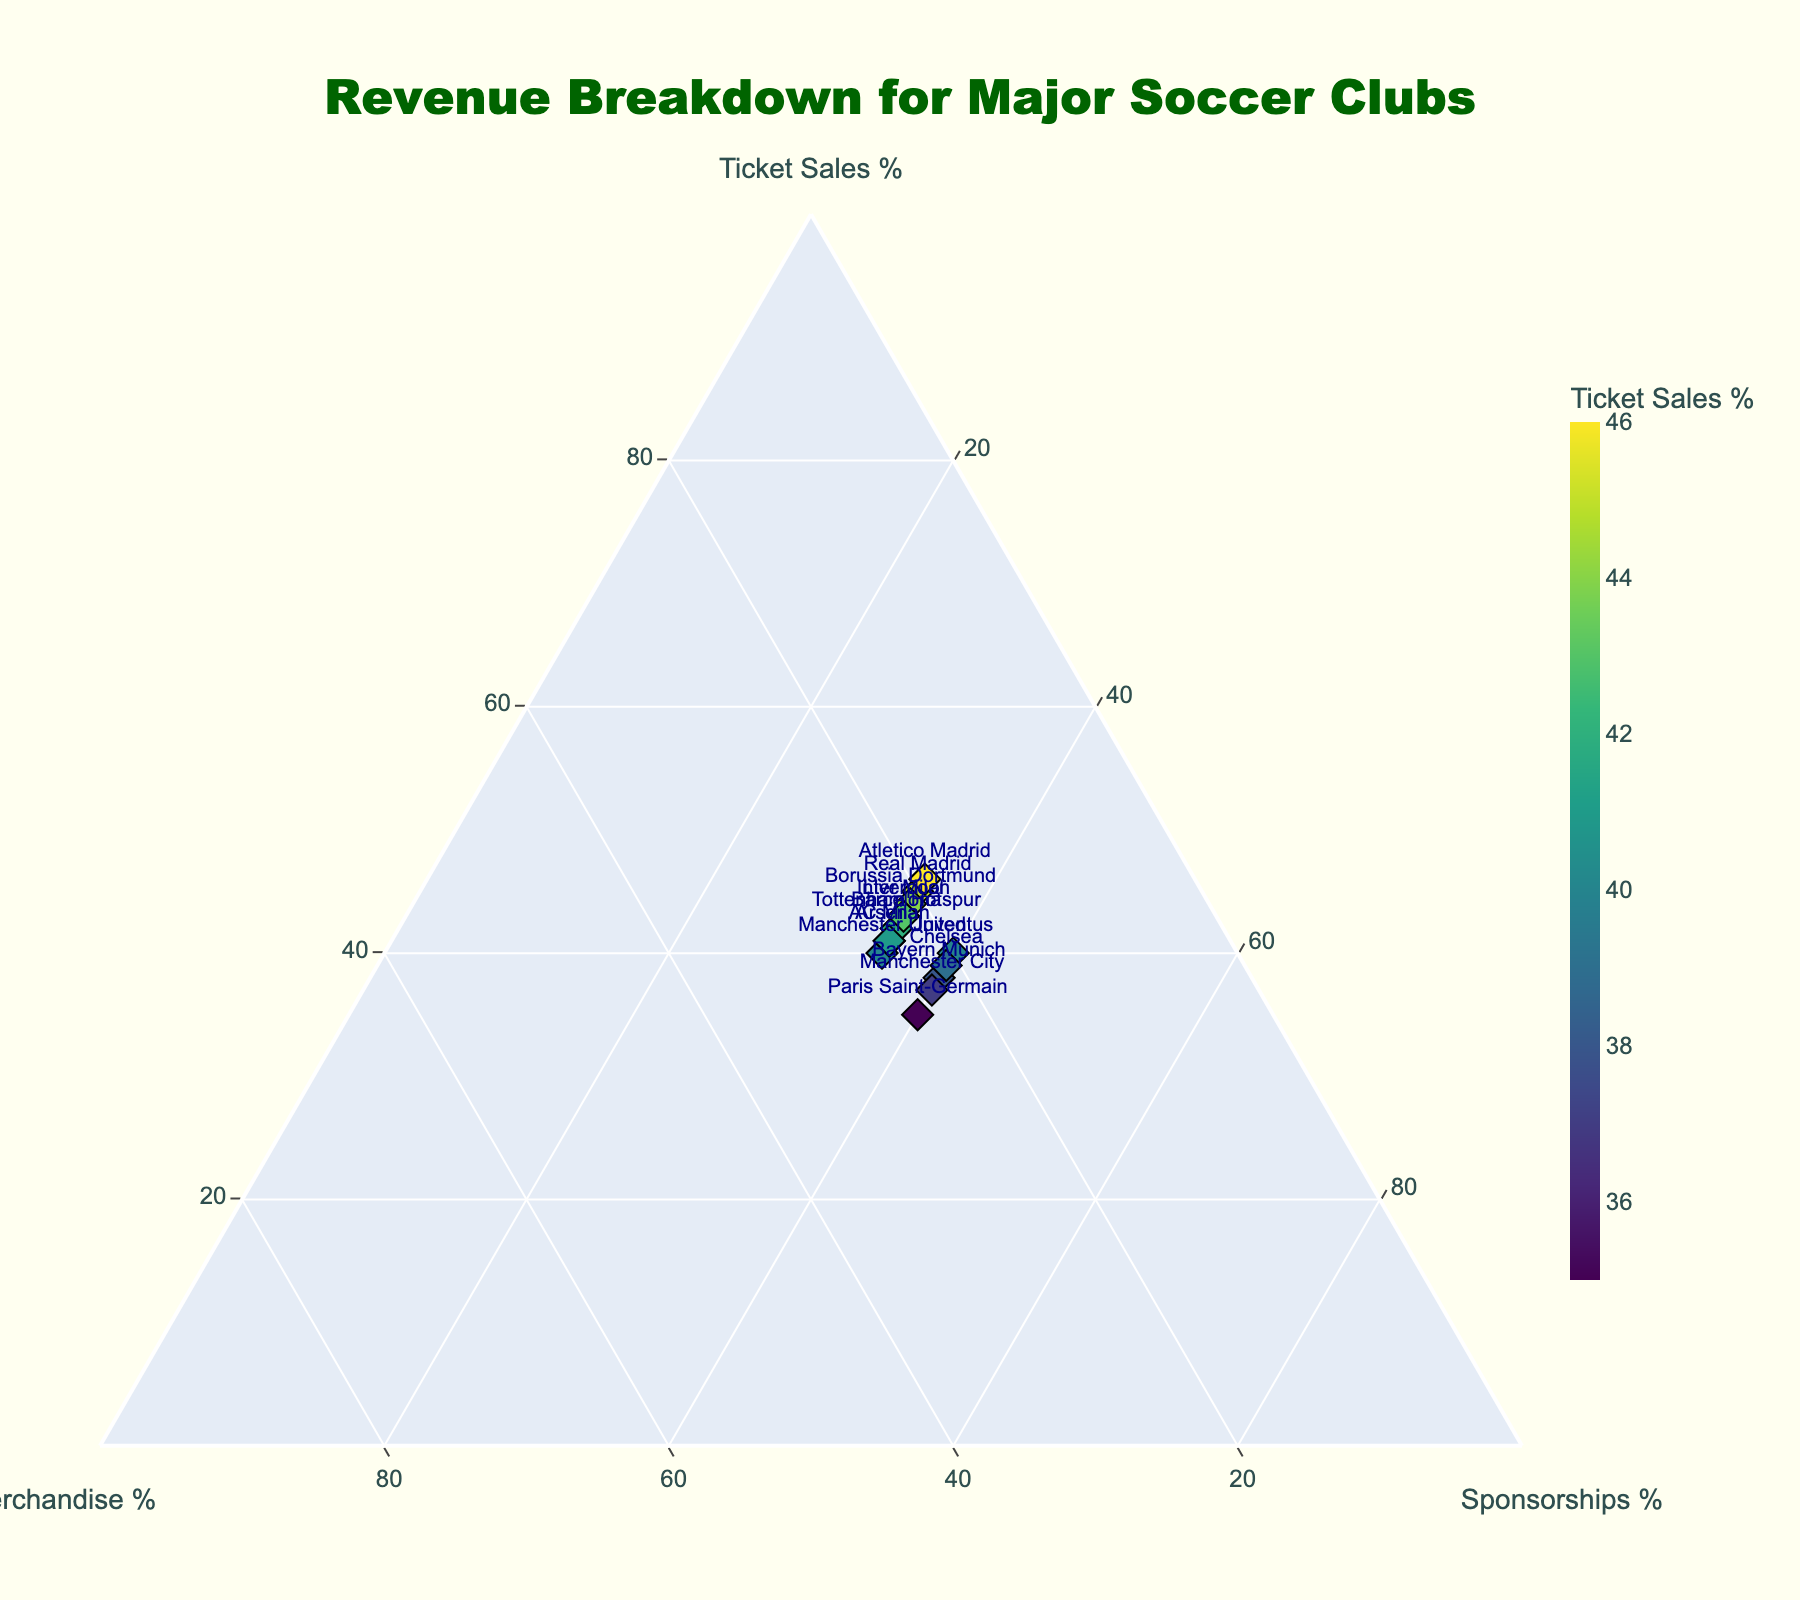What's the title of the plot? The title is displayed at the top center of the plot.
Answer: Revenue Breakdown for Major Soccer Clubs How many clubs have more than 40% revenue from ticket sales? Looking at the data points near the "Ticket Sales %" axis, find clubs with ticket sales above 40%. Real Madrid, Barcelona, Liverpool, Arsenal, Borussia Dortmund, Atletico Madrid, Tottenham Hotspur, and Inter Milan make up this list.
Answer: 8 Which club has the highest revenue percentage from merchandise? Check the data points close to the "Merchandise %" axis to find the highest value. Manchester United has 25%, the highest in the dataset.
Answer: Manchester United Which clubs have equal percentages in merchandise and sponsorships? Compare the values of merchandise and sponsorship for each club. Paris Saint-Germain and Juventus have equal percentages of 25% and 40%, respectively.
Answer: Paris Saint-Germain, Juventus How does the revenue from ticket sales for Bayern Munich compare to that of Juventus? Look at the values for ticket sales in the plot for Bayern Munich and Juventus. Bayern Munich has 38%, and Juventus has 40%.
Answer: Bayern Munich has less ticket sales than Juventus What's the difference in sponsorship revenue between Real Madrid and Manchester City? Look at the values for sponsorship in the plot for both clubs. Real Madrid has 35%, and Manchester City has 40%. The difference is 40% - 35% = 5%.
Answer: 5% Which club has a balanced revenue (equal) distribution across ticket sales, merchandise, and sponsorships? Check if any club has similar percentages across all three revenue sources. None of the clubs have an equal distribution; all have variation in their revenue percentages.
Answer: None What's the sum of merchandise revenue percentages for all clubs? Add up all the merchandise percentages from the dataset: 20 + 23 + 25 + 22 + 25 + 22 + 20 + 23 + 21 + 24 + 21 + 19 + 23 + 22 + 24 = 334.
Answer: 334 Which of these clubs have sponsorship percentages exactly equal to 35%? Look for the clubs with sponsorship percentages equal to 35%. Real Madrid, Barcelona, Manchester United, Liverpool, Arsenal, Borussia Dortmund, Atletico Madrid, Tottenham Hotspur, Inter Milan, AC Milan have 35%.
Answer: 10 clubs What's the median value of the ticket sales percentage for these clubs? Arrange the ticket sales percentages (35, 37, 38, 39, 40, 40, 40, 41, 41, 42, 42, 43, 43, 44, 45, 46) in ascending order. The median is the middle value of the sorted list. With 15 values, the middle is the 8th value: 41 (Juventus and AC Milan).
Answer: 41 